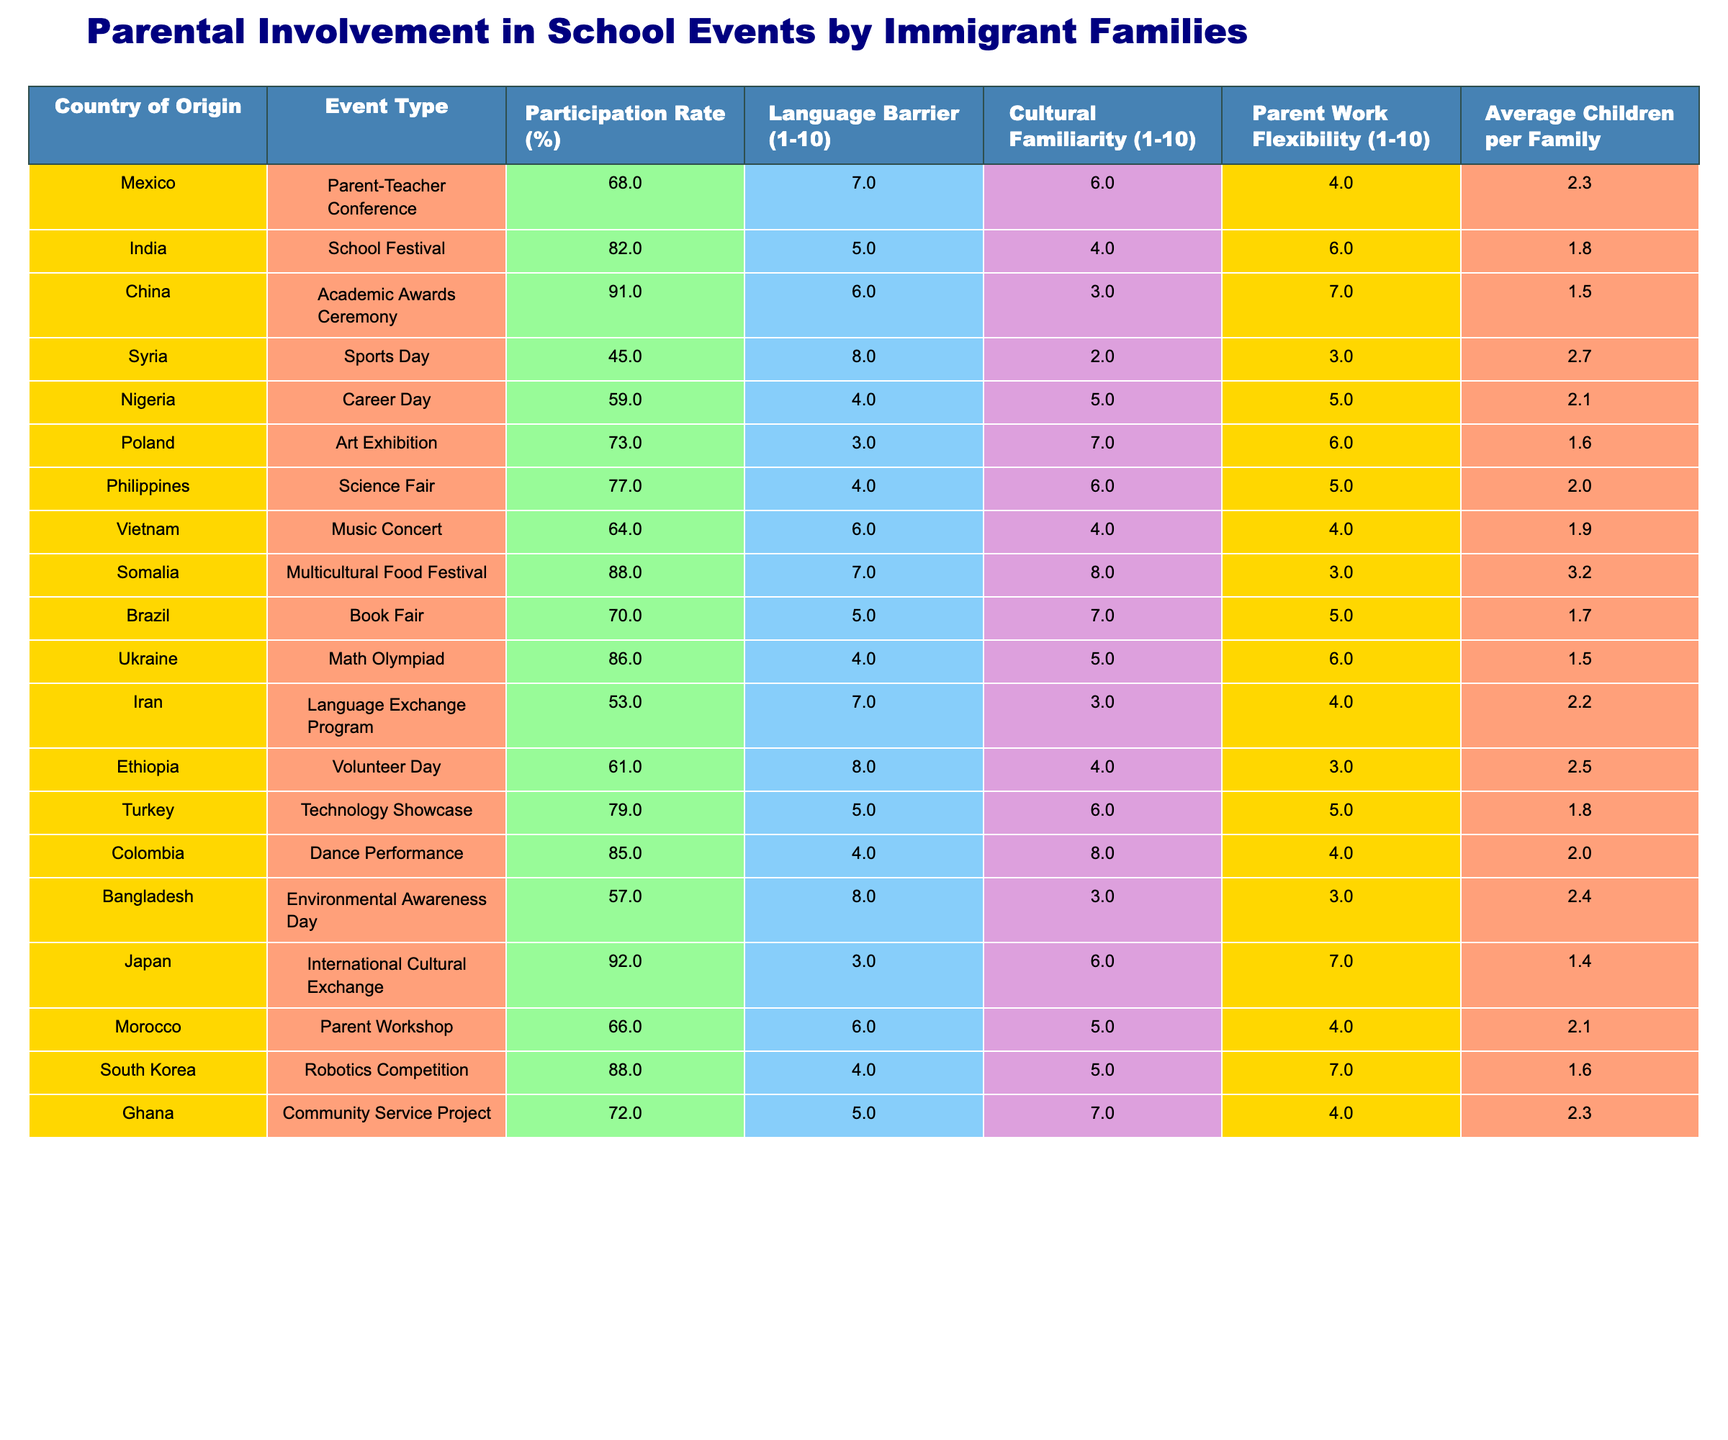What is the participation rate for immigrant families from China in the Academic Awards Ceremony? The table shows that the participation rate for families from China in this event is 91%.
Answer: 91% Which event had the lowest participation rate among the listed events? By comparing the participation rates, Sports Day from Syria had the lowest rate at 45%.
Answer: 45% What country has the highest language barrier score? The language barrier score for Syria is 8, which is the highest among the countries listed.
Answer: Syria Calculate the average participation rate for events involving families from Latin American countries. The Latin American countries in the table are Mexico, Colombia, and Brazil, with rates of 68%, 85%, and 70% respectively. The average is calculated as (68 + 85 + 70) / 3 = 74.33%.
Answer: 74.3% Is the participation rate for families from Nigeria higher than that of families from Somalia? Nigeria has a participation rate of 59% and Somalia has 88%. Since 59% is less than 88%, the statement is false.
Answer: No Which country shows a higher average number of children per family: Turkey or Iran? Turkey has 1.8 children per family while Iran has 2.2. Therefore, Iran shows a higher average number.
Answer: Iran What average participation rate can you calculate for Asian families (from India, China, Philippines, Vietnam, Japan, and South Korea)? The participation rates for these countries are 82%, 91%, 77%, 64%, 92%, and 88%, respectively. The average is (82 + 91 + 77 + 64 + 92 + 88) / 6 = 82.33%.
Answer: 82.3% Which event had the highest cultural familiarity score, and what was that score? The event with the highest cultural familiarity score is the Dance Performance from Colombia, scoring 8.
Answer: 8 How does the parent work flexibility score of families from Ethiopia compare to that of families from Ghana? Ethiopia has a score of 3 for parent work flexibility, while Ghana has a score of 4. Therefore, Ghana has a higher work flexibility score.
Answer: Ghana Which countries show participation rates above 80%? The countries with participation rates above 80% are India (82%), China (91%), Japan (92%), South Korea (88%), and Somalia (88%).
Answer: India, China, Japan, South Korea, Somalia What is the difference in the average children per family between Poland and Somalia? Poland has 1.6 average children per family, while Somalia has 3.2. The difference is 3.2 - 1.6 = 1.6.
Answer: 1.6 